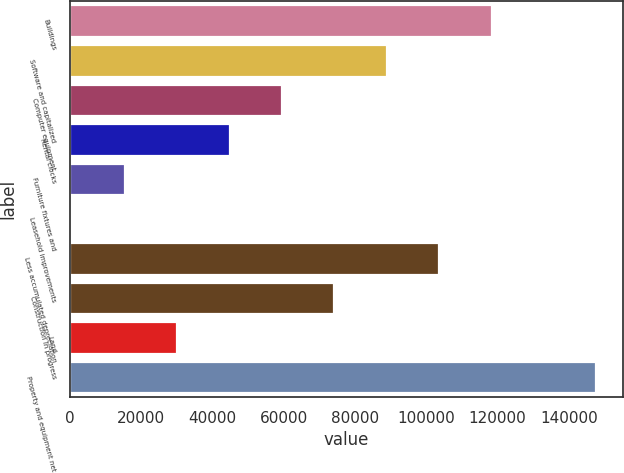Convert chart to OTSL. <chart><loc_0><loc_0><loc_500><loc_500><bar_chart><fcel>Buildings<fcel>Software and capitalized<fcel>Computer equipment<fcel>Rental clocks<fcel>Furniture fixtures and<fcel>Leasehold improvements<fcel>Less accumulated depreciation<fcel>Construction in progress<fcel>Land<fcel>Property and equipment net<nl><fcel>118317<fcel>88929.8<fcel>59542.2<fcel>44848.4<fcel>15460.8<fcel>767<fcel>103624<fcel>74236<fcel>30154.6<fcel>147705<nl></chart> 